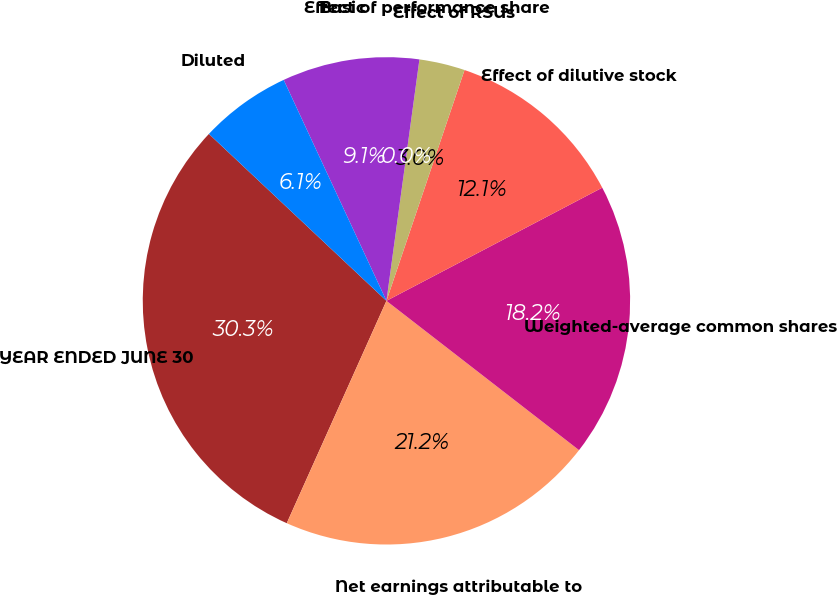<chart> <loc_0><loc_0><loc_500><loc_500><pie_chart><fcel>YEAR ENDED JUNE 30<fcel>Net earnings attributable to<fcel>Weighted-average common shares<fcel>Effect of dilutive stock<fcel>Effect of RSUs<fcel>Effect of performance share<fcel>Basic<fcel>Diluted<nl><fcel>30.3%<fcel>21.21%<fcel>18.18%<fcel>12.12%<fcel>3.03%<fcel>0.0%<fcel>9.09%<fcel>6.06%<nl></chart> 